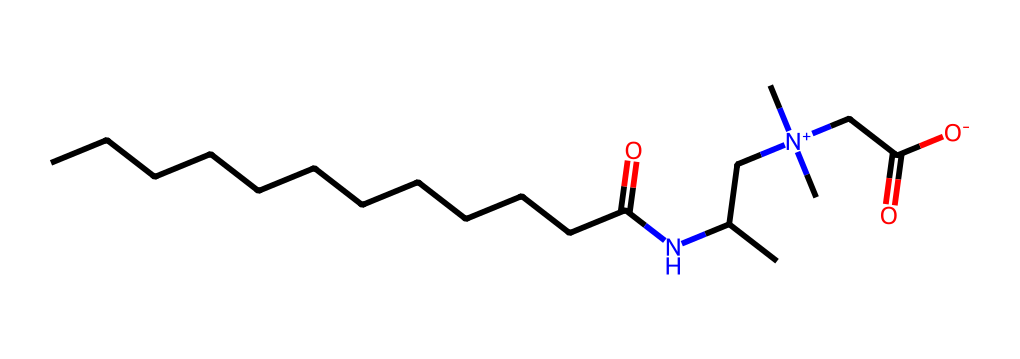what is the total number of carbon atoms in cocamidopropyl betaine? By analyzing the SMILES representation, we can count the number of carbon (C) atoms present. The structure shows a long carbon chain (CCCCCCCCCCCC) contributing 12 carbon atoms, and we also have additional carbon atoms from the rest of the structure, bringing the total to 14.
Answer: 14 how many nitrogen atoms are in the structure? Looking at the SMILES, there are two nitrogen (N) atoms indicated in the section NC(C)C and the [N+](C)(C) part. Therefore, counting these, we find there are 2 nitrogen atoms in total.
Answer: 2 what functional groups are present in cocamidopropyl betaine? In the structure, we can identify several functional groups including an amide group (–C(=O)N–), a quaternary ammonium group ([N+]), and a carboxylate group (–C(=O)[O-]). These groups provide the surfactant properties and solubility.
Answer: amide, quaternary ammonium, carboxylate which part of this chemical indicates it is a surfactant? Surfactants typically contain both hydrophilic (water-attractive) and hydrophobic (water-repelling) portions. In cocamidopropyl betaine, the presence of the quaternary ammonium group [N+] contributes to hydrophilicity, while the long carbon chain represents the hydrophobic tail. This balance allows it to function as a surfactant.
Answer: quaternary ammonium and long carbon chain what is the overall charge of cocamidopropyl betaine? In the given structure, the presence of the quaternary ammonium group [N+] indicates a positive charge, while the carboxylate group [O-] contributes a negative charge. However, within cocamidopropyl betaine, these charges balance each other, resulting in a net neutral charge.
Answer: neutral 